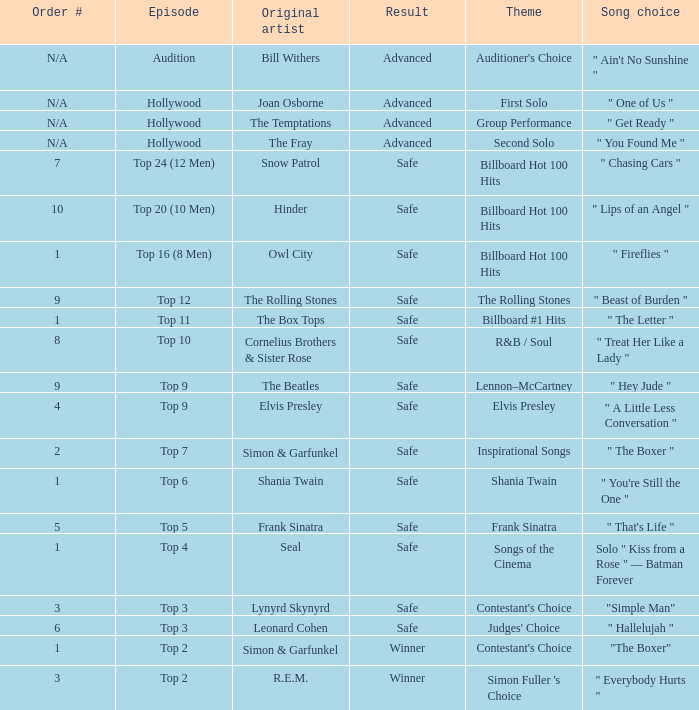The song choice " One of Us " has what themes? First Solo. 